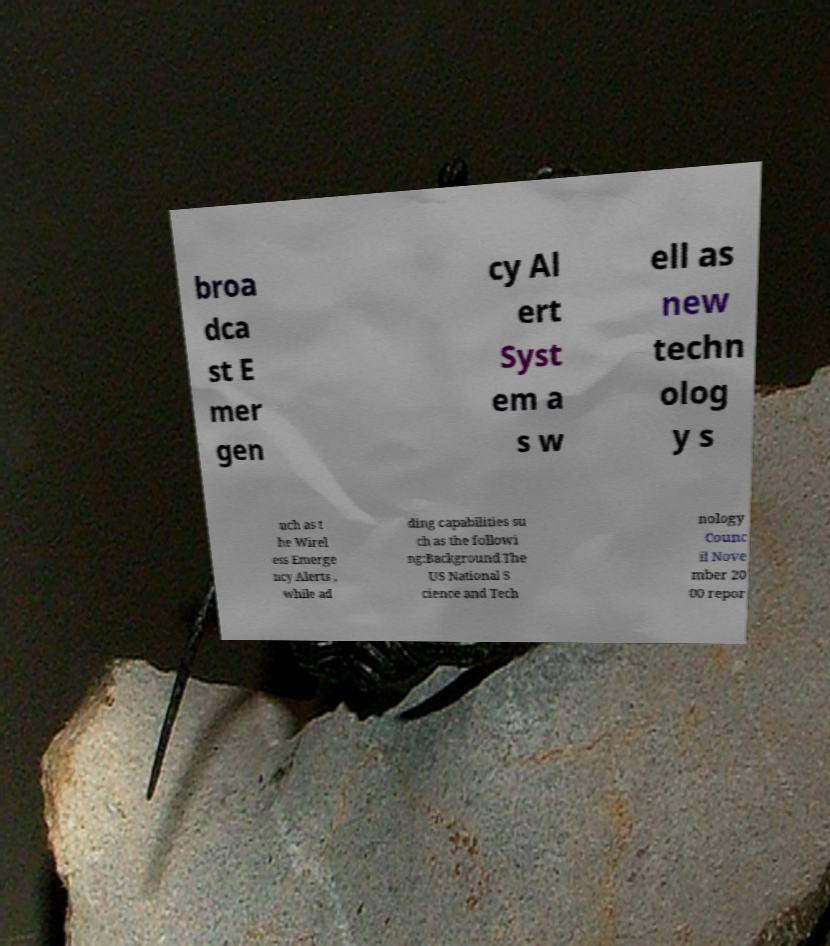Can you read and provide the text displayed in the image?This photo seems to have some interesting text. Can you extract and type it out for me? broa dca st E mer gen cy Al ert Syst em a s w ell as new techn olog y s uch as t he Wirel ess Emerge ncy Alerts , while ad ding capabilities su ch as the followi ng:Background.The US National S cience and Tech nology Counc il Nove mber 20 00 repor 